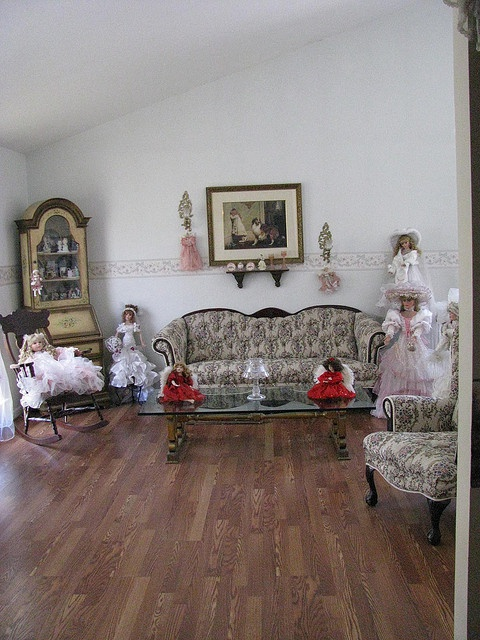Describe the objects in this image and their specific colors. I can see couch in darkgray, gray, and black tones, chair in darkgray, gray, and black tones, dining table in darkgray, gray, black, and maroon tones, and chair in darkgray, black, gray, and maroon tones in this image. 